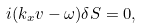<formula> <loc_0><loc_0><loc_500><loc_500>i ( k _ { x } v - \omega ) \delta S = 0 ,</formula> 